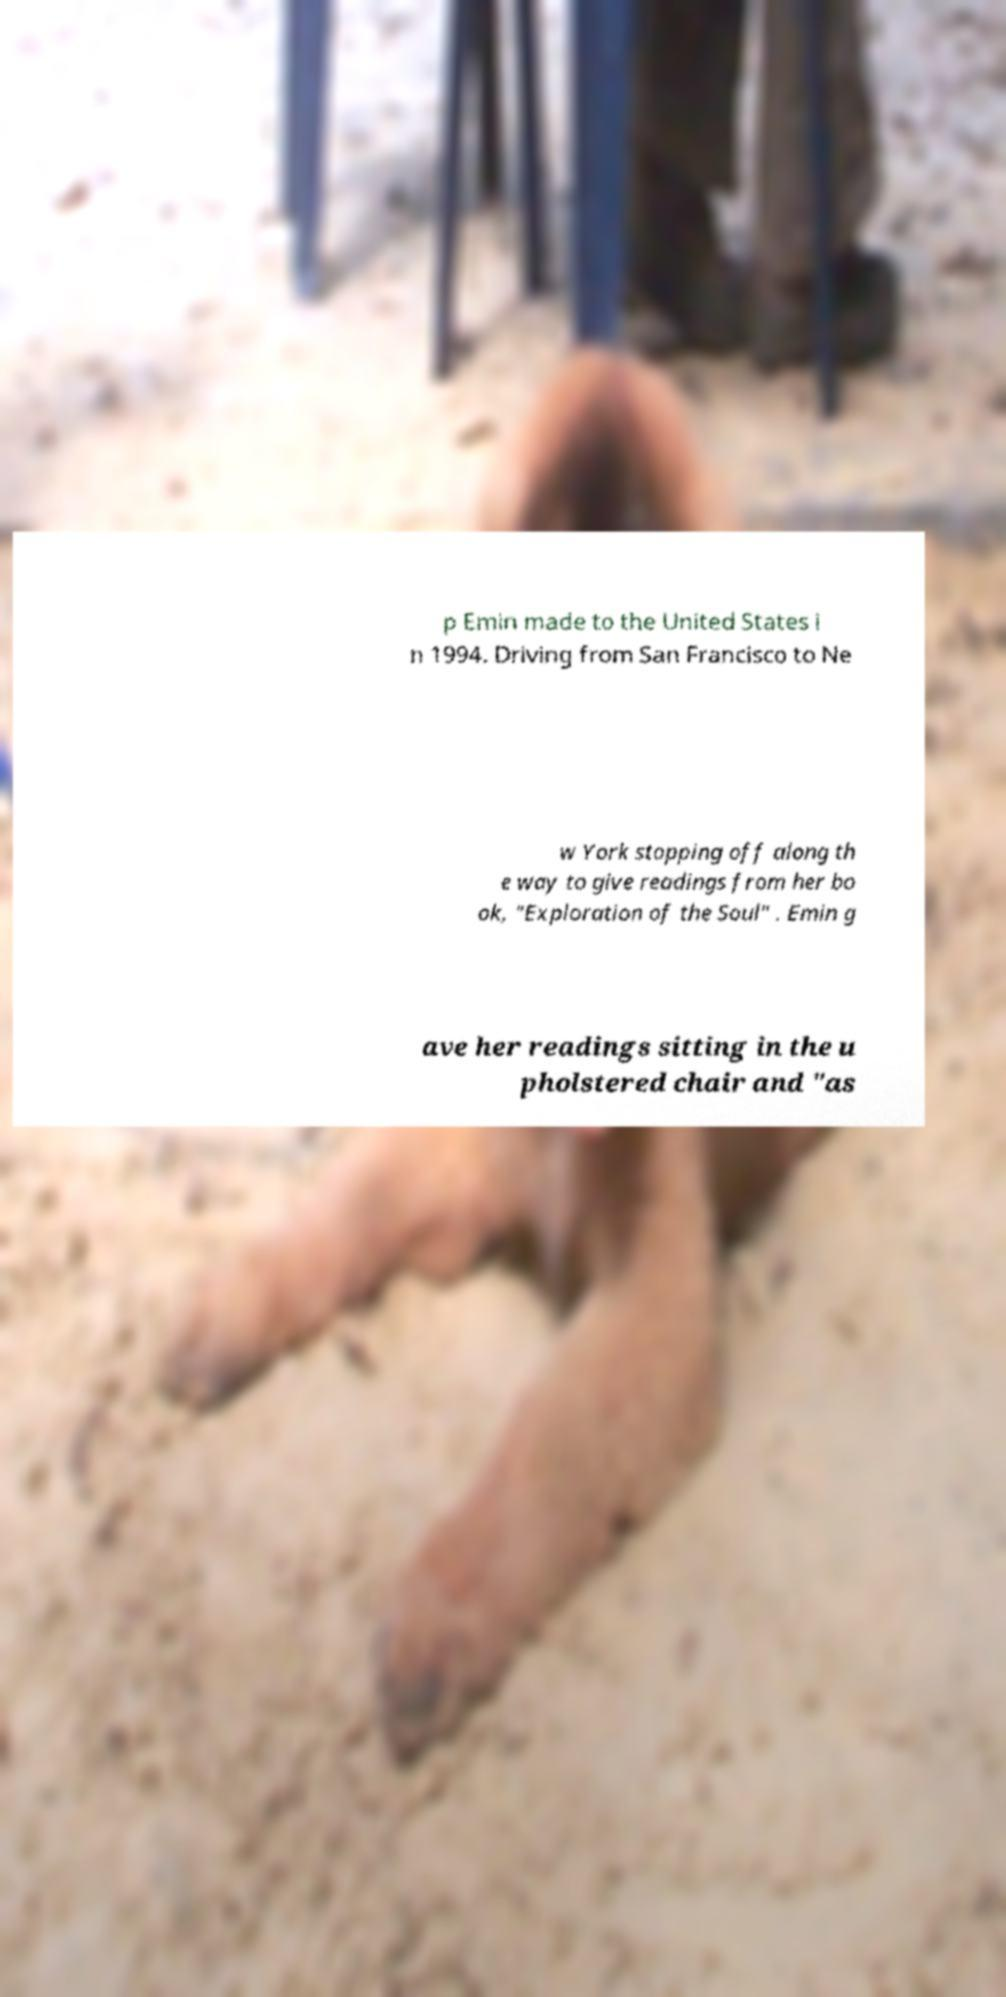Can you read and provide the text displayed in the image?This photo seems to have some interesting text. Can you extract and type it out for me? p Emin made to the United States i n 1994. Driving from San Francisco to Ne w York stopping off along th e way to give readings from her bo ok, "Exploration of the Soul" . Emin g ave her readings sitting in the u pholstered chair and "as 